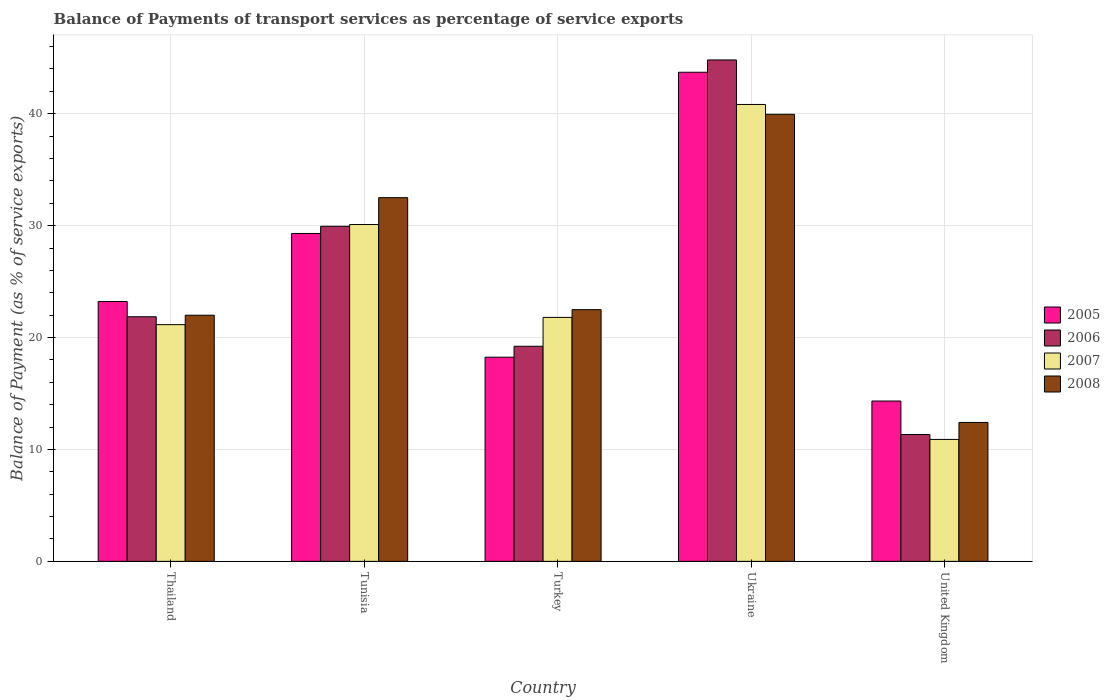How many different coloured bars are there?
Make the answer very short. 4. Are the number of bars per tick equal to the number of legend labels?
Your answer should be compact. Yes. Are the number of bars on each tick of the X-axis equal?
Your response must be concise. Yes. How many bars are there on the 2nd tick from the right?
Offer a very short reply. 4. What is the label of the 2nd group of bars from the left?
Provide a succinct answer. Tunisia. What is the balance of payments of transport services in 2006 in Turkey?
Provide a succinct answer. 19.22. Across all countries, what is the maximum balance of payments of transport services in 2006?
Your answer should be very brief. 44.81. Across all countries, what is the minimum balance of payments of transport services in 2007?
Keep it short and to the point. 10.9. In which country was the balance of payments of transport services in 2006 maximum?
Your response must be concise. Ukraine. What is the total balance of payments of transport services in 2008 in the graph?
Offer a very short reply. 129.35. What is the difference between the balance of payments of transport services in 2006 in Thailand and that in Tunisia?
Provide a short and direct response. -8.08. What is the difference between the balance of payments of transport services in 2008 in Turkey and the balance of payments of transport services in 2006 in Thailand?
Provide a succinct answer. 0.63. What is the average balance of payments of transport services in 2007 per country?
Ensure brevity in your answer.  24.96. What is the difference between the balance of payments of transport services of/in 2006 and balance of payments of transport services of/in 2007 in Ukraine?
Keep it short and to the point. 3.98. What is the ratio of the balance of payments of transport services in 2005 in Tunisia to that in Turkey?
Give a very brief answer. 1.61. What is the difference between the highest and the second highest balance of payments of transport services in 2006?
Your answer should be very brief. -22.95. What is the difference between the highest and the lowest balance of payments of transport services in 2007?
Your answer should be very brief. 29.93. Is it the case that in every country, the sum of the balance of payments of transport services in 2008 and balance of payments of transport services in 2005 is greater than the sum of balance of payments of transport services in 2007 and balance of payments of transport services in 2006?
Your answer should be very brief. No. What does the 1st bar from the left in Thailand represents?
Keep it short and to the point. 2005. What does the 4th bar from the right in Tunisia represents?
Your response must be concise. 2005. Is it the case that in every country, the sum of the balance of payments of transport services in 2008 and balance of payments of transport services in 2007 is greater than the balance of payments of transport services in 2005?
Provide a short and direct response. Yes. Are all the bars in the graph horizontal?
Your answer should be very brief. No. How many countries are there in the graph?
Provide a succinct answer. 5. What is the difference between two consecutive major ticks on the Y-axis?
Ensure brevity in your answer.  10. Are the values on the major ticks of Y-axis written in scientific E-notation?
Your response must be concise. No. Does the graph contain any zero values?
Your response must be concise. No. Where does the legend appear in the graph?
Provide a succinct answer. Center right. How many legend labels are there?
Ensure brevity in your answer.  4. What is the title of the graph?
Provide a short and direct response. Balance of Payments of transport services as percentage of service exports. Does "1962" appear as one of the legend labels in the graph?
Keep it short and to the point. No. What is the label or title of the Y-axis?
Your answer should be very brief. Balance of Payment (as % of service exports). What is the Balance of Payment (as % of service exports) in 2005 in Thailand?
Offer a terse response. 23.22. What is the Balance of Payment (as % of service exports) of 2006 in Thailand?
Give a very brief answer. 21.86. What is the Balance of Payment (as % of service exports) of 2007 in Thailand?
Make the answer very short. 21.15. What is the Balance of Payment (as % of service exports) in 2008 in Thailand?
Offer a very short reply. 22. What is the Balance of Payment (as % of service exports) in 2005 in Tunisia?
Give a very brief answer. 29.3. What is the Balance of Payment (as % of service exports) of 2006 in Tunisia?
Provide a short and direct response. 29.94. What is the Balance of Payment (as % of service exports) in 2007 in Tunisia?
Ensure brevity in your answer.  30.1. What is the Balance of Payment (as % of service exports) of 2008 in Tunisia?
Provide a succinct answer. 32.5. What is the Balance of Payment (as % of service exports) of 2005 in Turkey?
Your response must be concise. 18.24. What is the Balance of Payment (as % of service exports) of 2006 in Turkey?
Your response must be concise. 19.22. What is the Balance of Payment (as % of service exports) of 2007 in Turkey?
Offer a terse response. 21.8. What is the Balance of Payment (as % of service exports) in 2008 in Turkey?
Your answer should be compact. 22.49. What is the Balance of Payment (as % of service exports) in 2005 in Ukraine?
Provide a short and direct response. 43.71. What is the Balance of Payment (as % of service exports) in 2006 in Ukraine?
Ensure brevity in your answer.  44.81. What is the Balance of Payment (as % of service exports) in 2007 in Ukraine?
Keep it short and to the point. 40.83. What is the Balance of Payment (as % of service exports) of 2008 in Ukraine?
Your response must be concise. 39.95. What is the Balance of Payment (as % of service exports) in 2005 in United Kingdom?
Keep it short and to the point. 14.33. What is the Balance of Payment (as % of service exports) in 2006 in United Kingdom?
Your answer should be compact. 11.33. What is the Balance of Payment (as % of service exports) of 2007 in United Kingdom?
Your answer should be compact. 10.9. What is the Balance of Payment (as % of service exports) of 2008 in United Kingdom?
Your response must be concise. 12.41. Across all countries, what is the maximum Balance of Payment (as % of service exports) of 2005?
Make the answer very short. 43.71. Across all countries, what is the maximum Balance of Payment (as % of service exports) in 2006?
Offer a terse response. 44.81. Across all countries, what is the maximum Balance of Payment (as % of service exports) of 2007?
Ensure brevity in your answer.  40.83. Across all countries, what is the maximum Balance of Payment (as % of service exports) in 2008?
Offer a terse response. 39.95. Across all countries, what is the minimum Balance of Payment (as % of service exports) in 2005?
Your answer should be very brief. 14.33. Across all countries, what is the minimum Balance of Payment (as % of service exports) in 2006?
Give a very brief answer. 11.33. Across all countries, what is the minimum Balance of Payment (as % of service exports) in 2007?
Your answer should be compact. 10.9. Across all countries, what is the minimum Balance of Payment (as % of service exports) of 2008?
Your answer should be very brief. 12.41. What is the total Balance of Payment (as % of service exports) of 2005 in the graph?
Make the answer very short. 128.8. What is the total Balance of Payment (as % of service exports) in 2006 in the graph?
Keep it short and to the point. 127.16. What is the total Balance of Payment (as % of service exports) in 2007 in the graph?
Your answer should be very brief. 124.78. What is the total Balance of Payment (as % of service exports) in 2008 in the graph?
Ensure brevity in your answer.  129.35. What is the difference between the Balance of Payment (as % of service exports) in 2005 in Thailand and that in Tunisia?
Offer a terse response. -6.08. What is the difference between the Balance of Payment (as % of service exports) in 2006 in Thailand and that in Tunisia?
Ensure brevity in your answer.  -8.08. What is the difference between the Balance of Payment (as % of service exports) of 2007 in Thailand and that in Tunisia?
Offer a terse response. -8.95. What is the difference between the Balance of Payment (as % of service exports) in 2008 in Thailand and that in Tunisia?
Your response must be concise. -10.51. What is the difference between the Balance of Payment (as % of service exports) in 2005 in Thailand and that in Turkey?
Provide a succinct answer. 4.98. What is the difference between the Balance of Payment (as % of service exports) of 2006 in Thailand and that in Turkey?
Offer a very short reply. 2.64. What is the difference between the Balance of Payment (as % of service exports) in 2007 in Thailand and that in Turkey?
Keep it short and to the point. -0.65. What is the difference between the Balance of Payment (as % of service exports) of 2008 in Thailand and that in Turkey?
Make the answer very short. -0.5. What is the difference between the Balance of Payment (as % of service exports) in 2005 in Thailand and that in Ukraine?
Keep it short and to the point. -20.49. What is the difference between the Balance of Payment (as % of service exports) in 2006 in Thailand and that in Ukraine?
Provide a succinct answer. -22.95. What is the difference between the Balance of Payment (as % of service exports) in 2007 in Thailand and that in Ukraine?
Ensure brevity in your answer.  -19.68. What is the difference between the Balance of Payment (as % of service exports) of 2008 in Thailand and that in Ukraine?
Ensure brevity in your answer.  -17.95. What is the difference between the Balance of Payment (as % of service exports) of 2005 in Thailand and that in United Kingdom?
Your answer should be very brief. 8.89. What is the difference between the Balance of Payment (as % of service exports) in 2006 in Thailand and that in United Kingdom?
Offer a very short reply. 10.52. What is the difference between the Balance of Payment (as % of service exports) of 2007 in Thailand and that in United Kingdom?
Keep it short and to the point. 10.26. What is the difference between the Balance of Payment (as % of service exports) in 2008 in Thailand and that in United Kingdom?
Provide a short and direct response. 9.58. What is the difference between the Balance of Payment (as % of service exports) in 2005 in Tunisia and that in Turkey?
Offer a terse response. 11.06. What is the difference between the Balance of Payment (as % of service exports) in 2006 in Tunisia and that in Turkey?
Make the answer very short. 10.72. What is the difference between the Balance of Payment (as % of service exports) of 2007 in Tunisia and that in Turkey?
Keep it short and to the point. 8.3. What is the difference between the Balance of Payment (as % of service exports) in 2008 in Tunisia and that in Turkey?
Make the answer very short. 10.01. What is the difference between the Balance of Payment (as % of service exports) in 2005 in Tunisia and that in Ukraine?
Offer a very short reply. -14.41. What is the difference between the Balance of Payment (as % of service exports) of 2006 in Tunisia and that in Ukraine?
Provide a succinct answer. -14.87. What is the difference between the Balance of Payment (as % of service exports) in 2007 in Tunisia and that in Ukraine?
Your response must be concise. -10.73. What is the difference between the Balance of Payment (as % of service exports) of 2008 in Tunisia and that in Ukraine?
Your answer should be very brief. -7.45. What is the difference between the Balance of Payment (as % of service exports) in 2005 in Tunisia and that in United Kingdom?
Give a very brief answer. 14.97. What is the difference between the Balance of Payment (as % of service exports) of 2006 in Tunisia and that in United Kingdom?
Provide a short and direct response. 18.61. What is the difference between the Balance of Payment (as % of service exports) of 2007 in Tunisia and that in United Kingdom?
Offer a terse response. 19.2. What is the difference between the Balance of Payment (as % of service exports) in 2008 in Tunisia and that in United Kingdom?
Ensure brevity in your answer.  20.09. What is the difference between the Balance of Payment (as % of service exports) in 2005 in Turkey and that in Ukraine?
Keep it short and to the point. -25.46. What is the difference between the Balance of Payment (as % of service exports) in 2006 in Turkey and that in Ukraine?
Provide a succinct answer. -25.59. What is the difference between the Balance of Payment (as % of service exports) of 2007 in Turkey and that in Ukraine?
Your answer should be compact. -19.03. What is the difference between the Balance of Payment (as % of service exports) in 2008 in Turkey and that in Ukraine?
Give a very brief answer. -17.46. What is the difference between the Balance of Payment (as % of service exports) in 2005 in Turkey and that in United Kingdom?
Provide a short and direct response. 3.92. What is the difference between the Balance of Payment (as % of service exports) in 2006 in Turkey and that in United Kingdom?
Your response must be concise. 7.89. What is the difference between the Balance of Payment (as % of service exports) in 2007 in Turkey and that in United Kingdom?
Make the answer very short. 10.9. What is the difference between the Balance of Payment (as % of service exports) in 2008 in Turkey and that in United Kingdom?
Keep it short and to the point. 10.08. What is the difference between the Balance of Payment (as % of service exports) of 2005 in Ukraine and that in United Kingdom?
Your answer should be compact. 29.38. What is the difference between the Balance of Payment (as % of service exports) of 2006 in Ukraine and that in United Kingdom?
Provide a short and direct response. 33.47. What is the difference between the Balance of Payment (as % of service exports) of 2007 in Ukraine and that in United Kingdom?
Make the answer very short. 29.93. What is the difference between the Balance of Payment (as % of service exports) of 2008 in Ukraine and that in United Kingdom?
Your answer should be very brief. 27.54. What is the difference between the Balance of Payment (as % of service exports) of 2005 in Thailand and the Balance of Payment (as % of service exports) of 2006 in Tunisia?
Make the answer very short. -6.72. What is the difference between the Balance of Payment (as % of service exports) of 2005 in Thailand and the Balance of Payment (as % of service exports) of 2007 in Tunisia?
Ensure brevity in your answer.  -6.88. What is the difference between the Balance of Payment (as % of service exports) in 2005 in Thailand and the Balance of Payment (as % of service exports) in 2008 in Tunisia?
Keep it short and to the point. -9.28. What is the difference between the Balance of Payment (as % of service exports) in 2006 in Thailand and the Balance of Payment (as % of service exports) in 2007 in Tunisia?
Your response must be concise. -8.24. What is the difference between the Balance of Payment (as % of service exports) of 2006 in Thailand and the Balance of Payment (as % of service exports) of 2008 in Tunisia?
Offer a very short reply. -10.64. What is the difference between the Balance of Payment (as % of service exports) in 2007 in Thailand and the Balance of Payment (as % of service exports) in 2008 in Tunisia?
Offer a very short reply. -11.35. What is the difference between the Balance of Payment (as % of service exports) in 2005 in Thailand and the Balance of Payment (as % of service exports) in 2006 in Turkey?
Your response must be concise. 4. What is the difference between the Balance of Payment (as % of service exports) in 2005 in Thailand and the Balance of Payment (as % of service exports) in 2007 in Turkey?
Provide a short and direct response. 1.42. What is the difference between the Balance of Payment (as % of service exports) of 2005 in Thailand and the Balance of Payment (as % of service exports) of 2008 in Turkey?
Offer a very short reply. 0.73. What is the difference between the Balance of Payment (as % of service exports) of 2006 in Thailand and the Balance of Payment (as % of service exports) of 2007 in Turkey?
Your answer should be very brief. 0.06. What is the difference between the Balance of Payment (as % of service exports) of 2006 in Thailand and the Balance of Payment (as % of service exports) of 2008 in Turkey?
Provide a short and direct response. -0.63. What is the difference between the Balance of Payment (as % of service exports) in 2007 in Thailand and the Balance of Payment (as % of service exports) in 2008 in Turkey?
Your answer should be very brief. -1.34. What is the difference between the Balance of Payment (as % of service exports) of 2005 in Thailand and the Balance of Payment (as % of service exports) of 2006 in Ukraine?
Make the answer very short. -21.59. What is the difference between the Balance of Payment (as % of service exports) in 2005 in Thailand and the Balance of Payment (as % of service exports) in 2007 in Ukraine?
Your response must be concise. -17.61. What is the difference between the Balance of Payment (as % of service exports) of 2005 in Thailand and the Balance of Payment (as % of service exports) of 2008 in Ukraine?
Provide a succinct answer. -16.73. What is the difference between the Balance of Payment (as % of service exports) in 2006 in Thailand and the Balance of Payment (as % of service exports) in 2007 in Ukraine?
Your response must be concise. -18.97. What is the difference between the Balance of Payment (as % of service exports) of 2006 in Thailand and the Balance of Payment (as % of service exports) of 2008 in Ukraine?
Ensure brevity in your answer.  -18.09. What is the difference between the Balance of Payment (as % of service exports) in 2007 in Thailand and the Balance of Payment (as % of service exports) in 2008 in Ukraine?
Your response must be concise. -18.8. What is the difference between the Balance of Payment (as % of service exports) of 2005 in Thailand and the Balance of Payment (as % of service exports) of 2006 in United Kingdom?
Your answer should be very brief. 11.89. What is the difference between the Balance of Payment (as % of service exports) of 2005 in Thailand and the Balance of Payment (as % of service exports) of 2007 in United Kingdom?
Your response must be concise. 12.32. What is the difference between the Balance of Payment (as % of service exports) in 2005 in Thailand and the Balance of Payment (as % of service exports) in 2008 in United Kingdom?
Offer a terse response. 10.81. What is the difference between the Balance of Payment (as % of service exports) in 2006 in Thailand and the Balance of Payment (as % of service exports) in 2007 in United Kingdom?
Offer a very short reply. 10.96. What is the difference between the Balance of Payment (as % of service exports) in 2006 in Thailand and the Balance of Payment (as % of service exports) in 2008 in United Kingdom?
Your answer should be very brief. 9.44. What is the difference between the Balance of Payment (as % of service exports) in 2007 in Thailand and the Balance of Payment (as % of service exports) in 2008 in United Kingdom?
Give a very brief answer. 8.74. What is the difference between the Balance of Payment (as % of service exports) of 2005 in Tunisia and the Balance of Payment (as % of service exports) of 2006 in Turkey?
Keep it short and to the point. 10.08. What is the difference between the Balance of Payment (as % of service exports) of 2005 in Tunisia and the Balance of Payment (as % of service exports) of 2007 in Turkey?
Ensure brevity in your answer.  7.5. What is the difference between the Balance of Payment (as % of service exports) in 2005 in Tunisia and the Balance of Payment (as % of service exports) in 2008 in Turkey?
Ensure brevity in your answer.  6.81. What is the difference between the Balance of Payment (as % of service exports) of 2006 in Tunisia and the Balance of Payment (as % of service exports) of 2007 in Turkey?
Your answer should be very brief. 8.14. What is the difference between the Balance of Payment (as % of service exports) in 2006 in Tunisia and the Balance of Payment (as % of service exports) in 2008 in Turkey?
Ensure brevity in your answer.  7.45. What is the difference between the Balance of Payment (as % of service exports) in 2007 in Tunisia and the Balance of Payment (as % of service exports) in 2008 in Turkey?
Provide a short and direct response. 7.61. What is the difference between the Balance of Payment (as % of service exports) in 2005 in Tunisia and the Balance of Payment (as % of service exports) in 2006 in Ukraine?
Your answer should be compact. -15.51. What is the difference between the Balance of Payment (as % of service exports) of 2005 in Tunisia and the Balance of Payment (as % of service exports) of 2007 in Ukraine?
Give a very brief answer. -11.53. What is the difference between the Balance of Payment (as % of service exports) of 2005 in Tunisia and the Balance of Payment (as % of service exports) of 2008 in Ukraine?
Ensure brevity in your answer.  -10.65. What is the difference between the Balance of Payment (as % of service exports) in 2006 in Tunisia and the Balance of Payment (as % of service exports) in 2007 in Ukraine?
Your answer should be compact. -10.89. What is the difference between the Balance of Payment (as % of service exports) of 2006 in Tunisia and the Balance of Payment (as % of service exports) of 2008 in Ukraine?
Offer a terse response. -10.01. What is the difference between the Balance of Payment (as % of service exports) in 2007 in Tunisia and the Balance of Payment (as % of service exports) in 2008 in Ukraine?
Provide a succinct answer. -9.85. What is the difference between the Balance of Payment (as % of service exports) in 2005 in Tunisia and the Balance of Payment (as % of service exports) in 2006 in United Kingdom?
Offer a very short reply. 17.97. What is the difference between the Balance of Payment (as % of service exports) in 2005 in Tunisia and the Balance of Payment (as % of service exports) in 2007 in United Kingdom?
Offer a terse response. 18.4. What is the difference between the Balance of Payment (as % of service exports) of 2005 in Tunisia and the Balance of Payment (as % of service exports) of 2008 in United Kingdom?
Keep it short and to the point. 16.89. What is the difference between the Balance of Payment (as % of service exports) of 2006 in Tunisia and the Balance of Payment (as % of service exports) of 2007 in United Kingdom?
Give a very brief answer. 19.05. What is the difference between the Balance of Payment (as % of service exports) of 2006 in Tunisia and the Balance of Payment (as % of service exports) of 2008 in United Kingdom?
Your answer should be very brief. 17.53. What is the difference between the Balance of Payment (as % of service exports) of 2007 in Tunisia and the Balance of Payment (as % of service exports) of 2008 in United Kingdom?
Make the answer very short. 17.69. What is the difference between the Balance of Payment (as % of service exports) in 2005 in Turkey and the Balance of Payment (as % of service exports) in 2006 in Ukraine?
Make the answer very short. -26.56. What is the difference between the Balance of Payment (as % of service exports) of 2005 in Turkey and the Balance of Payment (as % of service exports) of 2007 in Ukraine?
Ensure brevity in your answer.  -22.58. What is the difference between the Balance of Payment (as % of service exports) in 2005 in Turkey and the Balance of Payment (as % of service exports) in 2008 in Ukraine?
Your response must be concise. -21.7. What is the difference between the Balance of Payment (as % of service exports) of 2006 in Turkey and the Balance of Payment (as % of service exports) of 2007 in Ukraine?
Offer a terse response. -21.61. What is the difference between the Balance of Payment (as % of service exports) of 2006 in Turkey and the Balance of Payment (as % of service exports) of 2008 in Ukraine?
Make the answer very short. -20.73. What is the difference between the Balance of Payment (as % of service exports) of 2007 in Turkey and the Balance of Payment (as % of service exports) of 2008 in Ukraine?
Keep it short and to the point. -18.15. What is the difference between the Balance of Payment (as % of service exports) of 2005 in Turkey and the Balance of Payment (as % of service exports) of 2006 in United Kingdom?
Your response must be concise. 6.91. What is the difference between the Balance of Payment (as % of service exports) of 2005 in Turkey and the Balance of Payment (as % of service exports) of 2007 in United Kingdom?
Your answer should be compact. 7.35. What is the difference between the Balance of Payment (as % of service exports) in 2005 in Turkey and the Balance of Payment (as % of service exports) in 2008 in United Kingdom?
Offer a terse response. 5.83. What is the difference between the Balance of Payment (as % of service exports) of 2006 in Turkey and the Balance of Payment (as % of service exports) of 2007 in United Kingdom?
Your response must be concise. 8.32. What is the difference between the Balance of Payment (as % of service exports) in 2006 in Turkey and the Balance of Payment (as % of service exports) in 2008 in United Kingdom?
Your response must be concise. 6.81. What is the difference between the Balance of Payment (as % of service exports) of 2007 in Turkey and the Balance of Payment (as % of service exports) of 2008 in United Kingdom?
Provide a succinct answer. 9.39. What is the difference between the Balance of Payment (as % of service exports) of 2005 in Ukraine and the Balance of Payment (as % of service exports) of 2006 in United Kingdom?
Your response must be concise. 32.37. What is the difference between the Balance of Payment (as % of service exports) of 2005 in Ukraine and the Balance of Payment (as % of service exports) of 2007 in United Kingdom?
Offer a terse response. 32.81. What is the difference between the Balance of Payment (as % of service exports) in 2005 in Ukraine and the Balance of Payment (as % of service exports) in 2008 in United Kingdom?
Your answer should be very brief. 31.29. What is the difference between the Balance of Payment (as % of service exports) in 2006 in Ukraine and the Balance of Payment (as % of service exports) in 2007 in United Kingdom?
Your answer should be very brief. 33.91. What is the difference between the Balance of Payment (as % of service exports) of 2006 in Ukraine and the Balance of Payment (as % of service exports) of 2008 in United Kingdom?
Provide a succinct answer. 32.39. What is the difference between the Balance of Payment (as % of service exports) in 2007 in Ukraine and the Balance of Payment (as % of service exports) in 2008 in United Kingdom?
Your response must be concise. 28.41. What is the average Balance of Payment (as % of service exports) of 2005 per country?
Your answer should be very brief. 25.76. What is the average Balance of Payment (as % of service exports) in 2006 per country?
Your answer should be very brief. 25.43. What is the average Balance of Payment (as % of service exports) of 2007 per country?
Provide a short and direct response. 24.96. What is the average Balance of Payment (as % of service exports) of 2008 per country?
Your answer should be compact. 25.87. What is the difference between the Balance of Payment (as % of service exports) in 2005 and Balance of Payment (as % of service exports) in 2006 in Thailand?
Provide a succinct answer. 1.36. What is the difference between the Balance of Payment (as % of service exports) of 2005 and Balance of Payment (as % of service exports) of 2007 in Thailand?
Your response must be concise. 2.07. What is the difference between the Balance of Payment (as % of service exports) in 2005 and Balance of Payment (as % of service exports) in 2008 in Thailand?
Your answer should be compact. 1.23. What is the difference between the Balance of Payment (as % of service exports) of 2006 and Balance of Payment (as % of service exports) of 2007 in Thailand?
Offer a terse response. 0.7. What is the difference between the Balance of Payment (as % of service exports) in 2006 and Balance of Payment (as % of service exports) in 2008 in Thailand?
Provide a succinct answer. -0.14. What is the difference between the Balance of Payment (as % of service exports) of 2007 and Balance of Payment (as % of service exports) of 2008 in Thailand?
Make the answer very short. -0.84. What is the difference between the Balance of Payment (as % of service exports) in 2005 and Balance of Payment (as % of service exports) in 2006 in Tunisia?
Your answer should be compact. -0.64. What is the difference between the Balance of Payment (as % of service exports) of 2005 and Balance of Payment (as % of service exports) of 2008 in Tunisia?
Ensure brevity in your answer.  -3.2. What is the difference between the Balance of Payment (as % of service exports) of 2006 and Balance of Payment (as % of service exports) of 2007 in Tunisia?
Offer a very short reply. -0.16. What is the difference between the Balance of Payment (as % of service exports) in 2006 and Balance of Payment (as % of service exports) in 2008 in Tunisia?
Ensure brevity in your answer.  -2.56. What is the difference between the Balance of Payment (as % of service exports) of 2007 and Balance of Payment (as % of service exports) of 2008 in Tunisia?
Offer a terse response. -2.4. What is the difference between the Balance of Payment (as % of service exports) of 2005 and Balance of Payment (as % of service exports) of 2006 in Turkey?
Provide a succinct answer. -0.98. What is the difference between the Balance of Payment (as % of service exports) of 2005 and Balance of Payment (as % of service exports) of 2007 in Turkey?
Your answer should be very brief. -3.56. What is the difference between the Balance of Payment (as % of service exports) of 2005 and Balance of Payment (as % of service exports) of 2008 in Turkey?
Ensure brevity in your answer.  -4.25. What is the difference between the Balance of Payment (as % of service exports) in 2006 and Balance of Payment (as % of service exports) in 2007 in Turkey?
Keep it short and to the point. -2.58. What is the difference between the Balance of Payment (as % of service exports) in 2006 and Balance of Payment (as % of service exports) in 2008 in Turkey?
Provide a short and direct response. -3.27. What is the difference between the Balance of Payment (as % of service exports) of 2007 and Balance of Payment (as % of service exports) of 2008 in Turkey?
Ensure brevity in your answer.  -0.69. What is the difference between the Balance of Payment (as % of service exports) in 2005 and Balance of Payment (as % of service exports) in 2006 in Ukraine?
Make the answer very short. -1.1. What is the difference between the Balance of Payment (as % of service exports) of 2005 and Balance of Payment (as % of service exports) of 2007 in Ukraine?
Provide a short and direct response. 2.88. What is the difference between the Balance of Payment (as % of service exports) in 2005 and Balance of Payment (as % of service exports) in 2008 in Ukraine?
Make the answer very short. 3.76. What is the difference between the Balance of Payment (as % of service exports) of 2006 and Balance of Payment (as % of service exports) of 2007 in Ukraine?
Your answer should be compact. 3.98. What is the difference between the Balance of Payment (as % of service exports) in 2006 and Balance of Payment (as % of service exports) in 2008 in Ukraine?
Provide a succinct answer. 4.86. What is the difference between the Balance of Payment (as % of service exports) in 2005 and Balance of Payment (as % of service exports) in 2006 in United Kingdom?
Give a very brief answer. 2.99. What is the difference between the Balance of Payment (as % of service exports) of 2005 and Balance of Payment (as % of service exports) of 2007 in United Kingdom?
Provide a succinct answer. 3.43. What is the difference between the Balance of Payment (as % of service exports) of 2005 and Balance of Payment (as % of service exports) of 2008 in United Kingdom?
Offer a terse response. 1.91. What is the difference between the Balance of Payment (as % of service exports) in 2006 and Balance of Payment (as % of service exports) in 2007 in United Kingdom?
Your answer should be compact. 0.44. What is the difference between the Balance of Payment (as % of service exports) in 2006 and Balance of Payment (as % of service exports) in 2008 in United Kingdom?
Ensure brevity in your answer.  -1.08. What is the difference between the Balance of Payment (as % of service exports) in 2007 and Balance of Payment (as % of service exports) in 2008 in United Kingdom?
Keep it short and to the point. -1.52. What is the ratio of the Balance of Payment (as % of service exports) of 2005 in Thailand to that in Tunisia?
Your response must be concise. 0.79. What is the ratio of the Balance of Payment (as % of service exports) in 2006 in Thailand to that in Tunisia?
Give a very brief answer. 0.73. What is the ratio of the Balance of Payment (as % of service exports) of 2007 in Thailand to that in Tunisia?
Ensure brevity in your answer.  0.7. What is the ratio of the Balance of Payment (as % of service exports) of 2008 in Thailand to that in Tunisia?
Keep it short and to the point. 0.68. What is the ratio of the Balance of Payment (as % of service exports) in 2005 in Thailand to that in Turkey?
Make the answer very short. 1.27. What is the ratio of the Balance of Payment (as % of service exports) in 2006 in Thailand to that in Turkey?
Your response must be concise. 1.14. What is the ratio of the Balance of Payment (as % of service exports) of 2007 in Thailand to that in Turkey?
Offer a terse response. 0.97. What is the ratio of the Balance of Payment (as % of service exports) of 2008 in Thailand to that in Turkey?
Your answer should be very brief. 0.98. What is the ratio of the Balance of Payment (as % of service exports) of 2005 in Thailand to that in Ukraine?
Offer a terse response. 0.53. What is the ratio of the Balance of Payment (as % of service exports) of 2006 in Thailand to that in Ukraine?
Ensure brevity in your answer.  0.49. What is the ratio of the Balance of Payment (as % of service exports) of 2007 in Thailand to that in Ukraine?
Your answer should be compact. 0.52. What is the ratio of the Balance of Payment (as % of service exports) of 2008 in Thailand to that in Ukraine?
Your answer should be very brief. 0.55. What is the ratio of the Balance of Payment (as % of service exports) in 2005 in Thailand to that in United Kingdom?
Offer a very short reply. 1.62. What is the ratio of the Balance of Payment (as % of service exports) in 2006 in Thailand to that in United Kingdom?
Your answer should be compact. 1.93. What is the ratio of the Balance of Payment (as % of service exports) of 2007 in Thailand to that in United Kingdom?
Provide a succinct answer. 1.94. What is the ratio of the Balance of Payment (as % of service exports) of 2008 in Thailand to that in United Kingdom?
Provide a short and direct response. 1.77. What is the ratio of the Balance of Payment (as % of service exports) of 2005 in Tunisia to that in Turkey?
Offer a very short reply. 1.61. What is the ratio of the Balance of Payment (as % of service exports) of 2006 in Tunisia to that in Turkey?
Keep it short and to the point. 1.56. What is the ratio of the Balance of Payment (as % of service exports) of 2007 in Tunisia to that in Turkey?
Keep it short and to the point. 1.38. What is the ratio of the Balance of Payment (as % of service exports) of 2008 in Tunisia to that in Turkey?
Offer a terse response. 1.44. What is the ratio of the Balance of Payment (as % of service exports) in 2005 in Tunisia to that in Ukraine?
Offer a terse response. 0.67. What is the ratio of the Balance of Payment (as % of service exports) in 2006 in Tunisia to that in Ukraine?
Offer a terse response. 0.67. What is the ratio of the Balance of Payment (as % of service exports) of 2007 in Tunisia to that in Ukraine?
Keep it short and to the point. 0.74. What is the ratio of the Balance of Payment (as % of service exports) of 2008 in Tunisia to that in Ukraine?
Provide a succinct answer. 0.81. What is the ratio of the Balance of Payment (as % of service exports) of 2005 in Tunisia to that in United Kingdom?
Make the answer very short. 2.04. What is the ratio of the Balance of Payment (as % of service exports) in 2006 in Tunisia to that in United Kingdom?
Offer a very short reply. 2.64. What is the ratio of the Balance of Payment (as % of service exports) in 2007 in Tunisia to that in United Kingdom?
Offer a terse response. 2.76. What is the ratio of the Balance of Payment (as % of service exports) in 2008 in Tunisia to that in United Kingdom?
Your answer should be compact. 2.62. What is the ratio of the Balance of Payment (as % of service exports) in 2005 in Turkey to that in Ukraine?
Your answer should be compact. 0.42. What is the ratio of the Balance of Payment (as % of service exports) of 2006 in Turkey to that in Ukraine?
Your answer should be compact. 0.43. What is the ratio of the Balance of Payment (as % of service exports) of 2007 in Turkey to that in Ukraine?
Your answer should be very brief. 0.53. What is the ratio of the Balance of Payment (as % of service exports) in 2008 in Turkey to that in Ukraine?
Provide a short and direct response. 0.56. What is the ratio of the Balance of Payment (as % of service exports) of 2005 in Turkey to that in United Kingdom?
Provide a succinct answer. 1.27. What is the ratio of the Balance of Payment (as % of service exports) in 2006 in Turkey to that in United Kingdom?
Give a very brief answer. 1.7. What is the ratio of the Balance of Payment (as % of service exports) in 2007 in Turkey to that in United Kingdom?
Keep it short and to the point. 2. What is the ratio of the Balance of Payment (as % of service exports) in 2008 in Turkey to that in United Kingdom?
Your answer should be very brief. 1.81. What is the ratio of the Balance of Payment (as % of service exports) in 2005 in Ukraine to that in United Kingdom?
Offer a terse response. 3.05. What is the ratio of the Balance of Payment (as % of service exports) in 2006 in Ukraine to that in United Kingdom?
Provide a short and direct response. 3.95. What is the ratio of the Balance of Payment (as % of service exports) of 2007 in Ukraine to that in United Kingdom?
Your answer should be very brief. 3.75. What is the ratio of the Balance of Payment (as % of service exports) in 2008 in Ukraine to that in United Kingdom?
Offer a terse response. 3.22. What is the difference between the highest and the second highest Balance of Payment (as % of service exports) of 2005?
Your answer should be very brief. 14.41. What is the difference between the highest and the second highest Balance of Payment (as % of service exports) of 2006?
Your answer should be very brief. 14.87. What is the difference between the highest and the second highest Balance of Payment (as % of service exports) of 2007?
Give a very brief answer. 10.73. What is the difference between the highest and the second highest Balance of Payment (as % of service exports) of 2008?
Your answer should be very brief. 7.45. What is the difference between the highest and the lowest Balance of Payment (as % of service exports) in 2005?
Make the answer very short. 29.38. What is the difference between the highest and the lowest Balance of Payment (as % of service exports) in 2006?
Make the answer very short. 33.47. What is the difference between the highest and the lowest Balance of Payment (as % of service exports) in 2007?
Offer a very short reply. 29.93. What is the difference between the highest and the lowest Balance of Payment (as % of service exports) in 2008?
Ensure brevity in your answer.  27.54. 